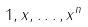<formula> <loc_0><loc_0><loc_500><loc_500>1 , x , \dots , x ^ { n }</formula> 